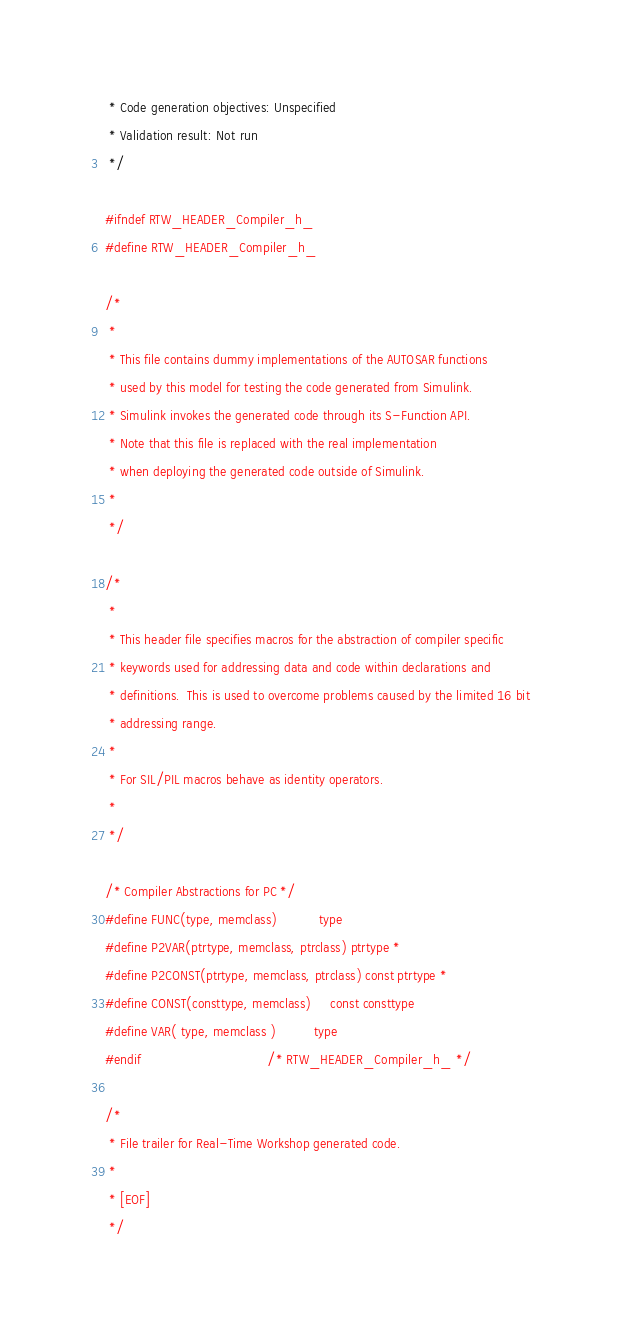<code> <loc_0><loc_0><loc_500><loc_500><_C_> * Code generation objectives: Unspecified
 * Validation result: Not run
 */

#ifndef RTW_HEADER_Compiler_h_
#define RTW_HEADER_Compiler_h_

/*
 *
 * This file contains dummy implementations of the AUTOSAR functions
 * used by this model for testing the code generated from Simulink.
 * Simulink invokes the generated code through its S-Function API.
 * Note that this file is replaced with the real implementation
 * when deploying the generated code outside of Simulink.
 *
 */

/*
 *
 * This header file specifies macros for the abstraction of compiler specific
 * keywords used for addressing data and code within declarations and
 * definitions.  This is used to overcome problems caused by the limited 16 bit
 * addressing range.
 *
 * For SIL/PIL macros behave as identity operators.
 *
 */

/* Compiler Abstractions for PC */
#define FUNC(type, memclass)           type
#define P2VAR(ptrtype, memclass, ptrclass) ptrtype *
#define P2CONST(ptrtype, memclass, ptrclass) const ptrtype *
#define CONST(consttype, memclass)     const consttype
#define VAR( type, memclass )          type
#endif                                 /* RTW_HEADER_Compiler_h_ */

/*
 * File trailer for Real-Time Workshop generated code.
 *
 * [EOF]
 */
</code> 